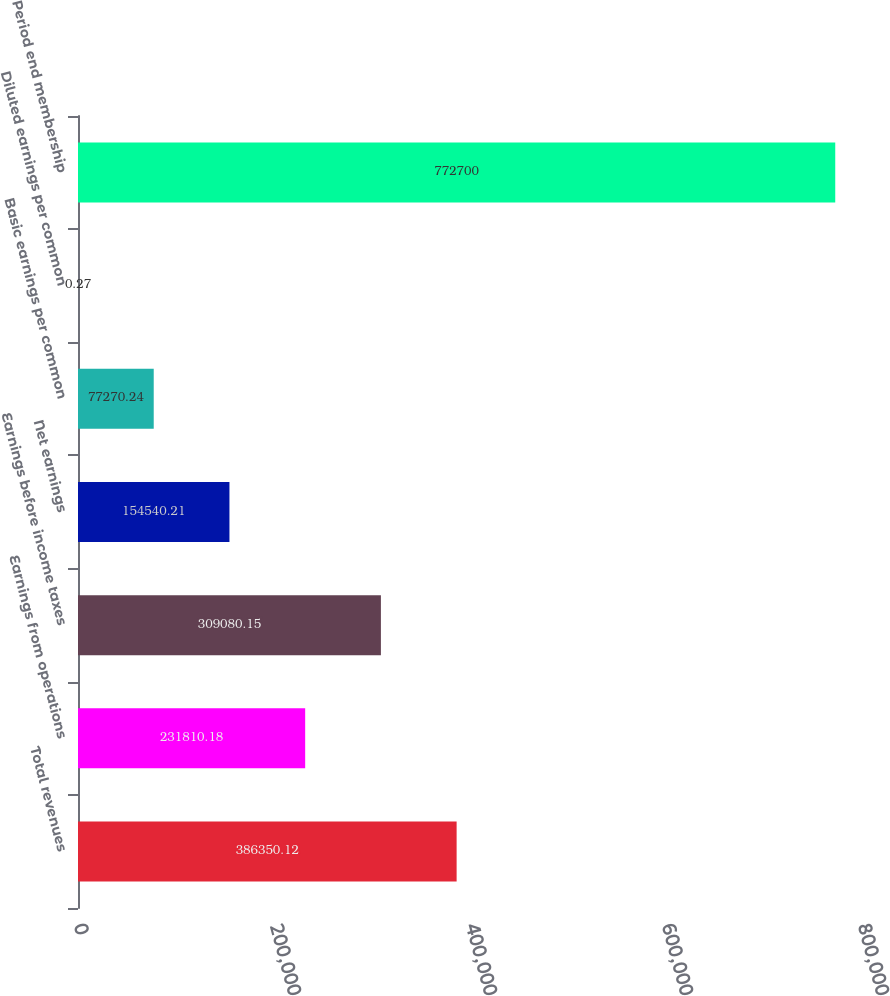<chart> <loc_0><loc_0><loc_500><loc_500><bar_chart><fcel>Total revenues<fcel>Earnings from operations<fcel>Earnings before income taxes<fcel>Net earnings<fcel>Basic earnings per common<fcel>Diluted earnings per common<fcel>Period end membership<nl><fcel>386350<fcel>231810<fcel>309080<fcel>154540<fcel>77270.2<fcel>0.27<fcel>772700<nl></chart> 